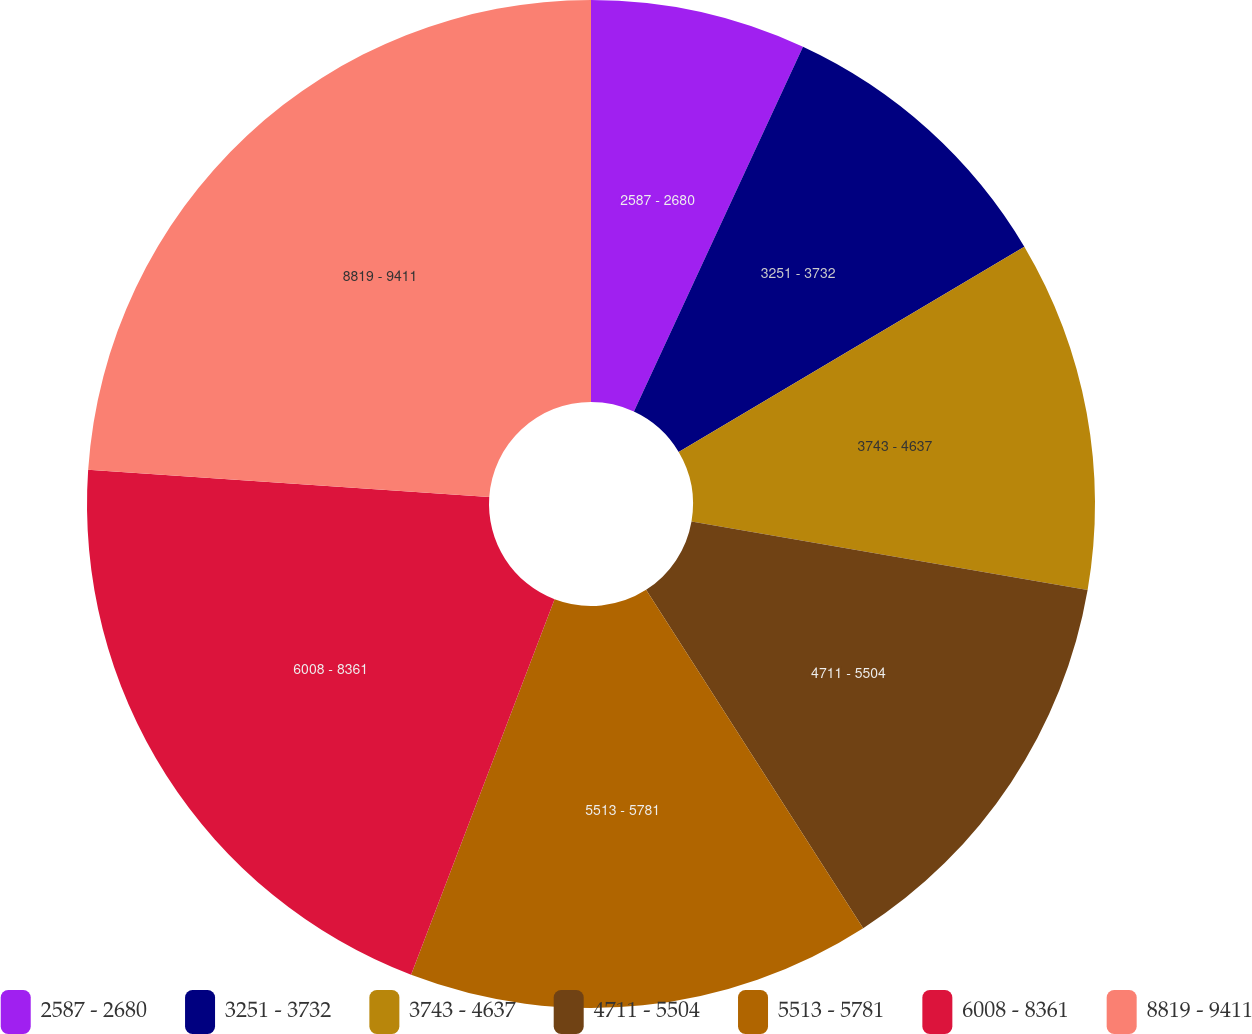Convert chart. <chart><loc_0><loc_0><loc_500><loc_500><pie_chart><fcel>2587 - 2680<fcel>3251 - 3732<fcel>3743 - 4637<fcel>4711 - 5504<fcel>5513 - 5781<fcel>6008 - 8361<fcel>8819 - 9411<nl><fcel>6.91%<fcel>9.56%<fcel>11.26%<fcel>13.19%<fcel>14.89%<fcel>20.27%<fcel>23.92%<nl></chart> 